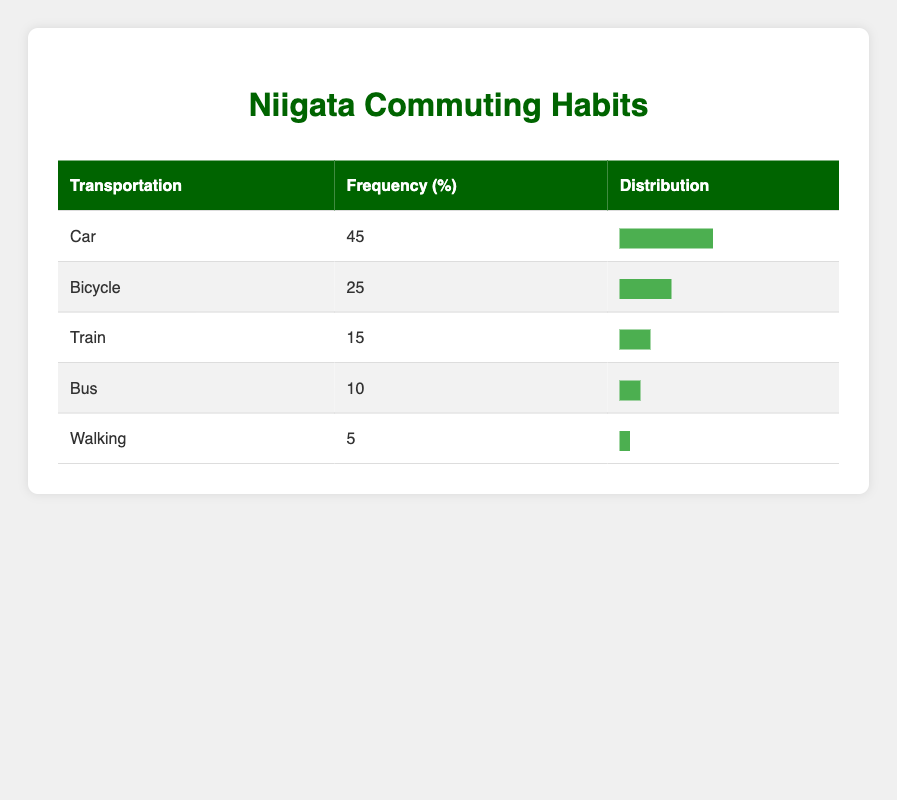What is the most commonly used mode of transportation among residents? The table shows that "Car" has the highest frequency at 45%. Therefore, it is the most commonly used mode of transportation.
Answer: Car How many residents use bicycles for commuting? According to the table, the frequency for "Bicycle" is 25, meaning 25 residents use bicycles for commuting.
Answer: 25 What is the percentage difference between the usage of cars and buses? The percentage for "Car" is 45% and for "Bus" is 10%. The difference is 45% - 10% = 35%.
Answer: 35% Is the frequency of walking greater than the frequency of using the train? The frequency for "Walking" is 5% and for "Train" is 15%. Since 5% is not greater than 15%, the statement is false.
Answer: No If you add the frequencies of train and bus users, what is the total number of residents using these two modes of transportation? The frequency for "Train" is 15 and for "Bus" is 10. Adding these together: 15 + 10 = 25. Therefore, 25 residents use either train or bus for commuting.
Answer: 25 What percentage of residents use either bicycles or walking? The percentage for "Bicycle" is 25% and for "Walking" is 5%. Adding these percentages gives 25% + 5% = 30%. Thus, 30% of residents use either bicycles or walking.
Answer: 30% How many more residents preferred using cars compared to walking? The frequency for "Car" is 45 and for "Walking" is 5. The difference is 45 - 5 = 40, meaning 40 more residents preferred cars over walking.
Answer: 40 Which mode of transportation is the least used by residents? The table indicates that "Walking" has the lowest frequency at 5%, making it the least used mode of transportation.
Answer: Walking What is the total frequency of transportation modes that are not cars? The frequencies for the other modes are: Bicycle (25), Train (15), Bus (10), and Walking (5). Adding these gives: 25 + 15 + 10 + 5 = 55. Therefore, the total frequency of non-car transportation is 55.
Answer: 55 